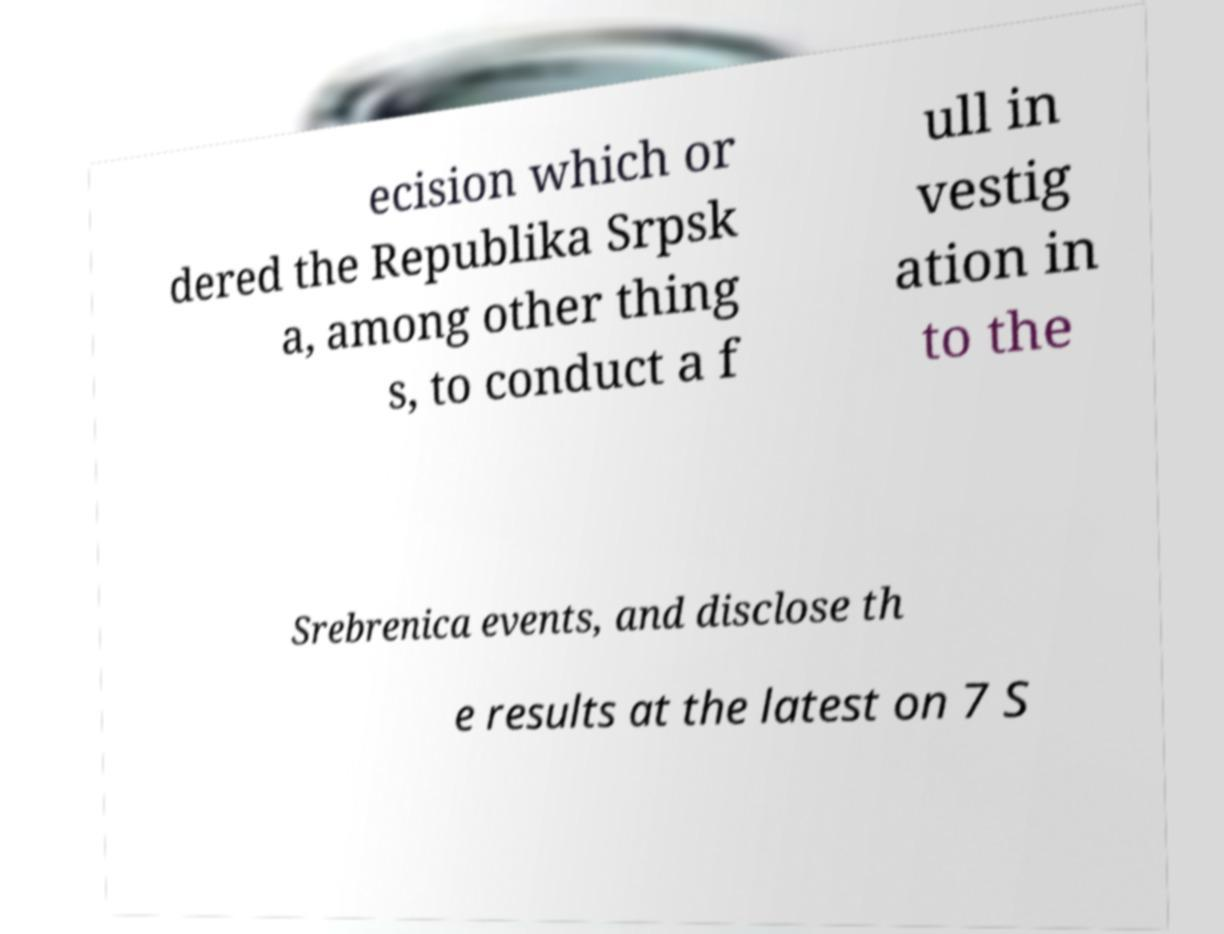Please read and relay the text visible in this image. What does it say? ecision which or dered the Republika Srpsk a, among other thing s, to conduct a f ull in vestig ation in to the Srebrenica events, and disclose th e results at the latest on 7 S 